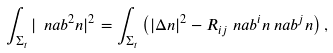<formula> <loc_0><loc_0><loc_500><loc_500>\int _ { \Sigma _ { t } } | \ n a b ^ { 2 } n | ^ { 2 } & = \int _ { \Sigma _ { t } } \left ( | \Delta n | ^ { 2 } - R _ { i j } \ n a b ^ { i } n \ n a b ^ { j } n \right ) ,</formula> 